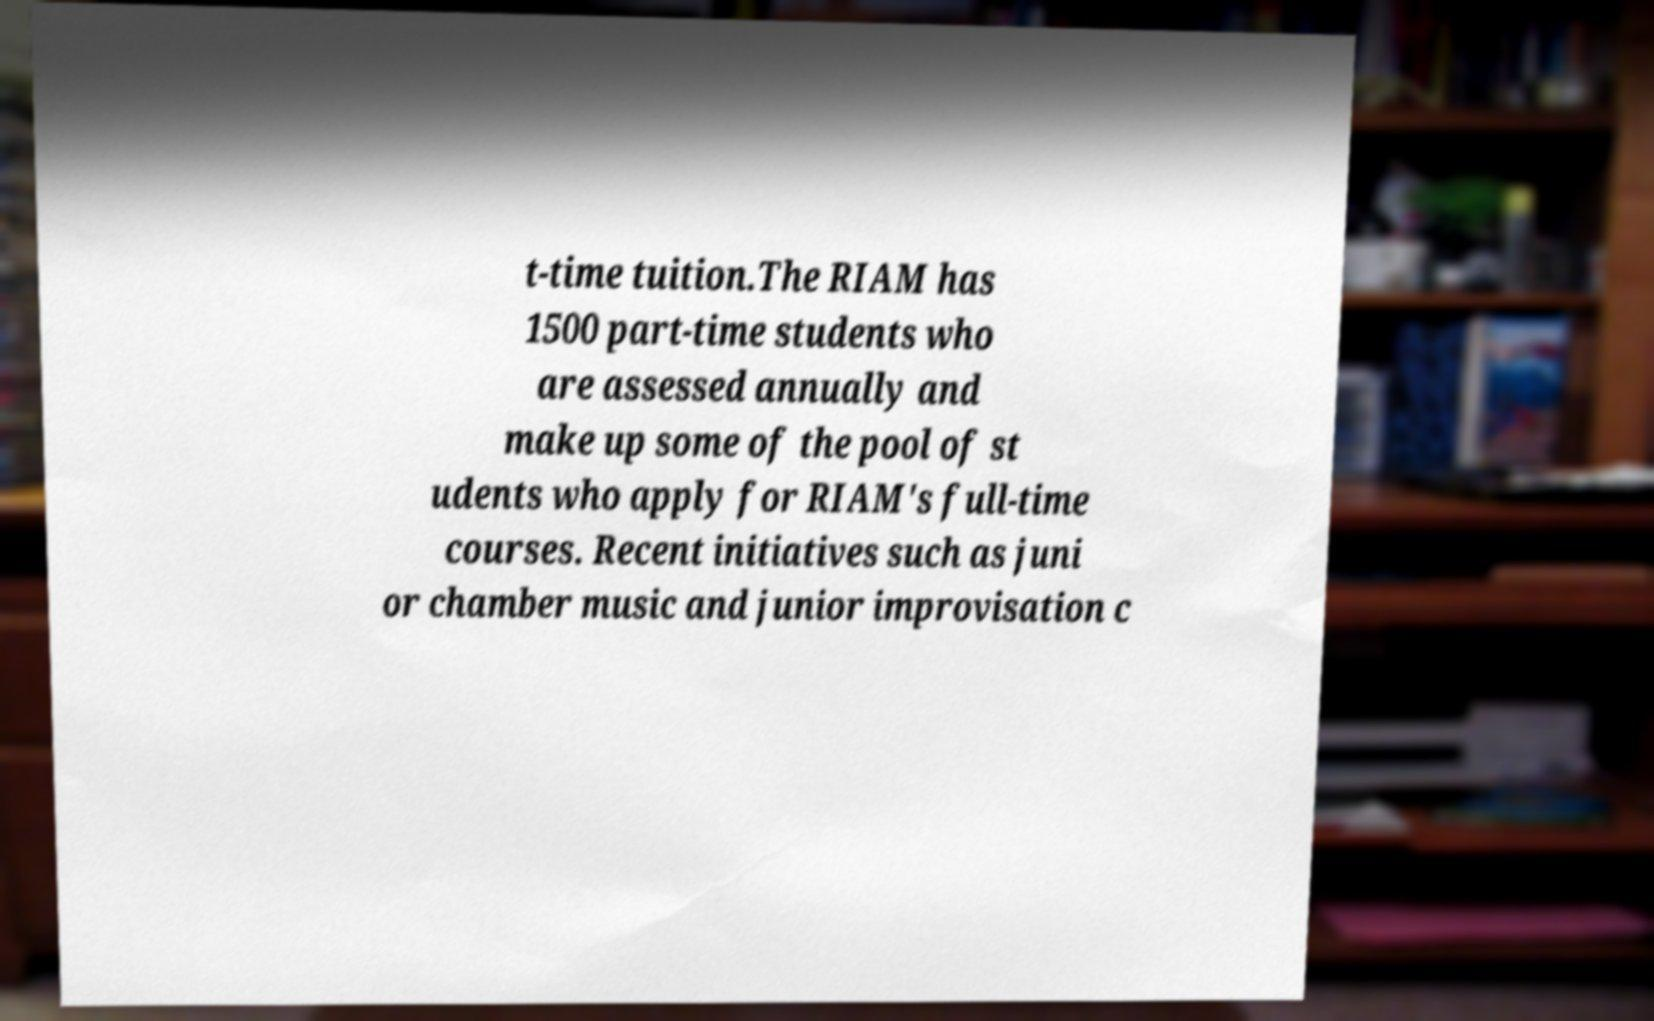Please identify and transcribe the text found in this image. t-time tuition.The RIAM has 1500 part-time students who are assessed annually and make up some of the pool of st udents who apply for RIAM's full-time courses. Recent initiatives such as juni or chamber music and junior improvisation c 